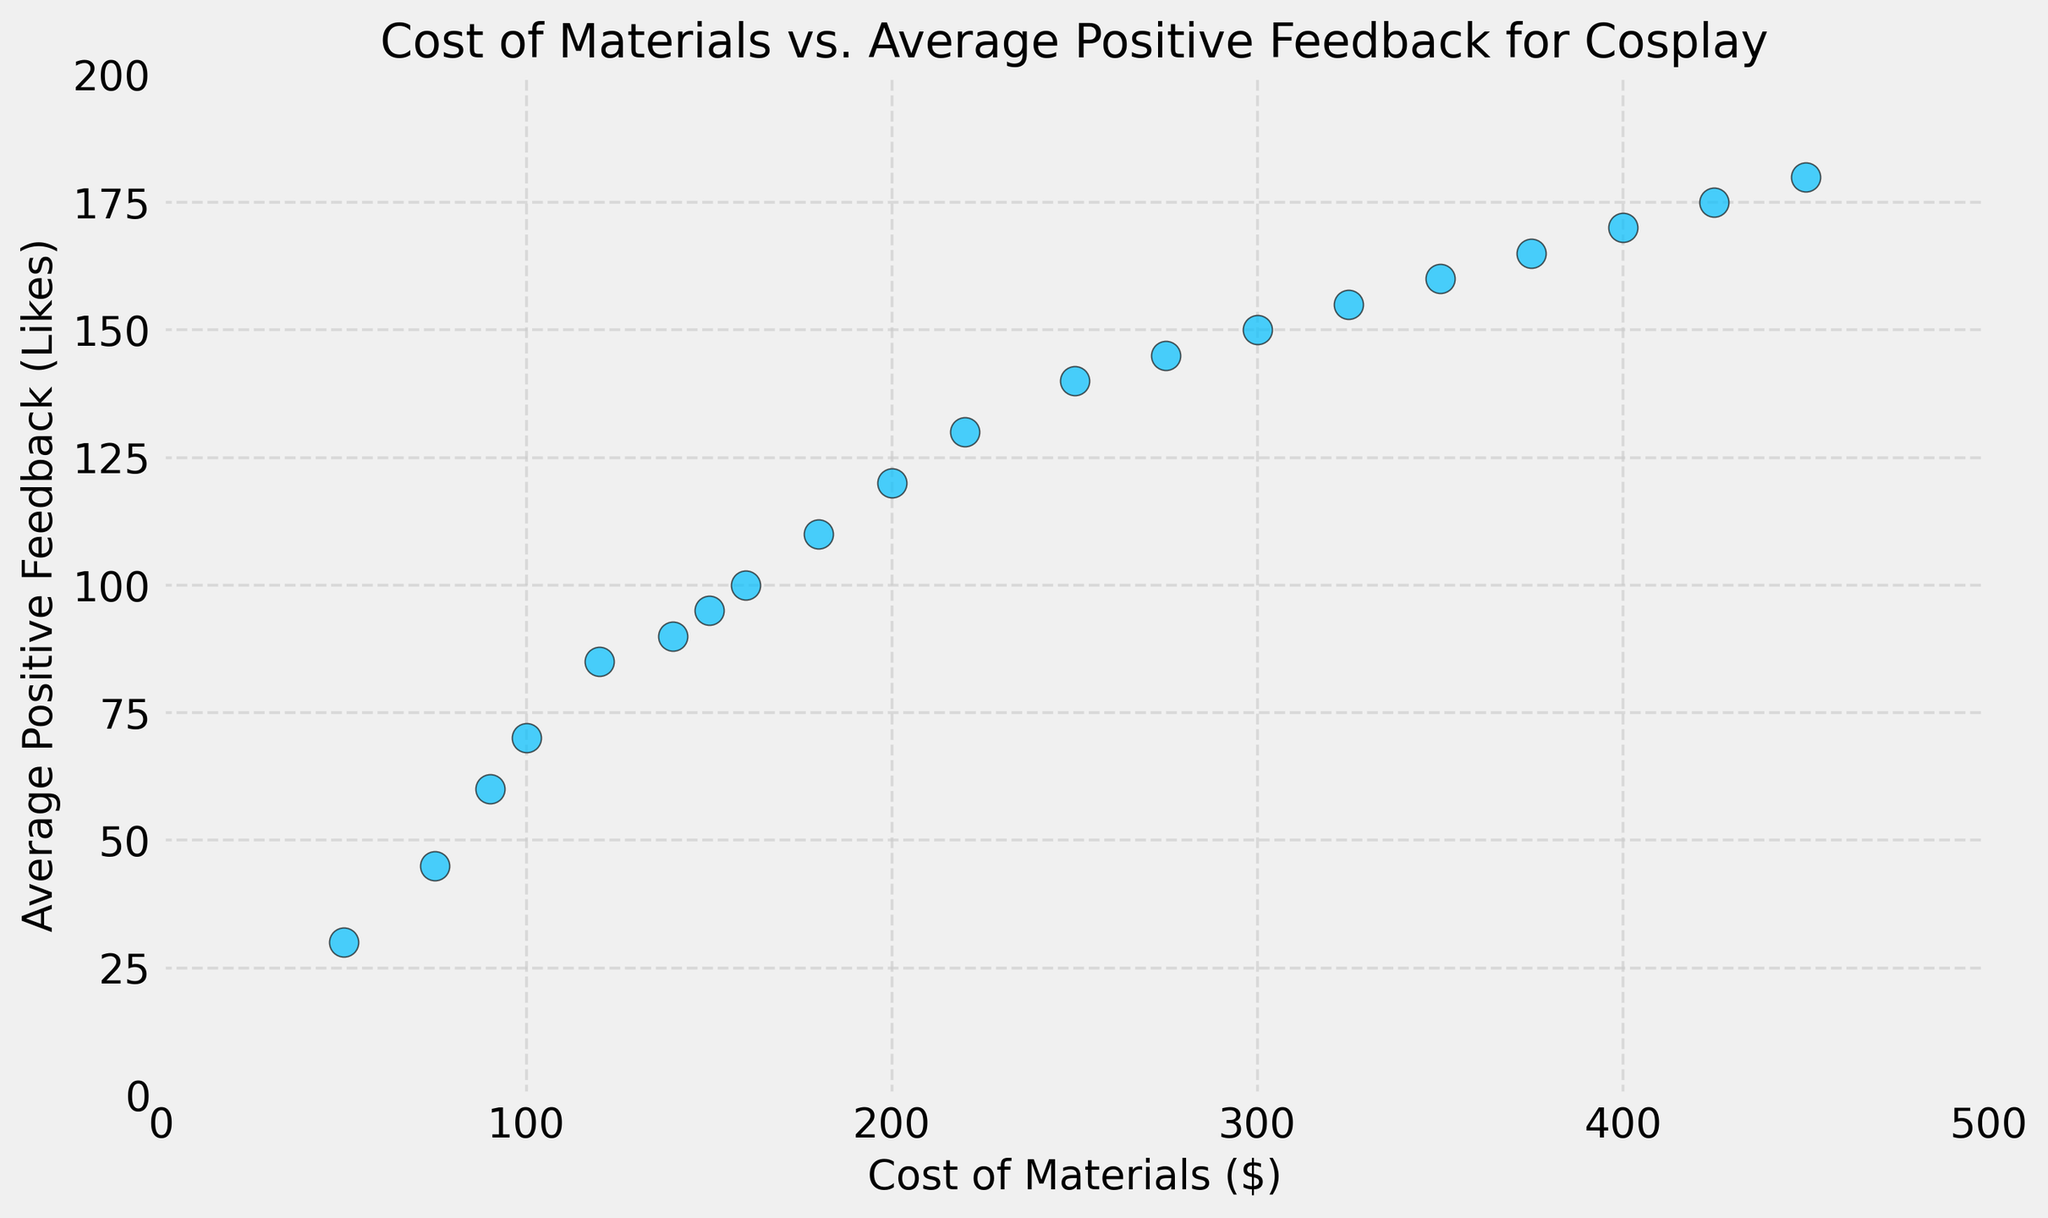How would you describe the overall trend between the cost of materials and the average positive feedback? The overall trend shows that as the cost of materials increases, the average positive feedback tends to increase as well. This is evident as the scatter points are generally moving upwards and to the right.
Answer: Increasing trend Which data point has the highest average positive feedback, and what does that signify about its cost of materials? The data point with the highest average positive feedback is 180 likes, and it corresponds to a cost of materials of $450. This signifies that the most expensive cosplay received the most positive feedback in this dataset.
Answer: $450 What is the difference in average positive feedback between the cosplay with the highest cost of materials and the cosplay with the lowest cost of materials? The highest cost of materials is $450 with 180 likes, and the lowest is $50 with 30 likes. The difference in average positive feedback is 180 - 30 = 150.
Answer: 150 Is there any data point where a higher cost of materials does not lead to a higher average positive feedback? No, based on the figure, higher costs of materials consistently lead to higher average positive feedback through all data points. This is visible as there are no points deviating from the overall trend.
Answer: No What can you infer about the distribution of average positive feedback across different costs of materials within the range of $200 to $400? Within the range of $200 to $400, the average positive feedback increases steadily. It shows that as cosplayers invest more in materials within this range, the feedback tends to significantly improve. The trend within this specific range follows the overall positive correlation.
Answer: Steady increase What is the average cost of materials for cosplays that achieve an average positive feedback of at least 100 likes? The data points with 100 or more likes are at costs of $160, $180, $200, $220, $250, $275, $300, $325, $350, $375, $400, $425, and $450. Summing these: 160 + 180 + 200 + 220 + 250 + 275 + 300 + 325 + 350 + 375 + 400 + 425 + 450 = 3910. The average is 3910 / 13 = 300.77.
Answer: 300.77 If you were to estimate the average positive feedback for a cosplay with a cost of materials around $100, what would it be, and why? Based on the scatter plot, a cost of $100 corresponds to an average positive feedback of 70. This specific data point aligns with the overall upward trend seen in the figure.
Answer: 70 How does the spacing of data points between $50 and $200 compare to the spacing of data points between $200 and $450? The spacing between $50 and $200 shows a denser clustering of data points, indicating more variance within the lower cost range. Between $200 and $450, the points are more spread out due to higher intervals in cost and feedback. This suggests higher investments in materials lead to more significant increases in positive feedback.
Answer: Denser in lower range, more spread out in higher range 